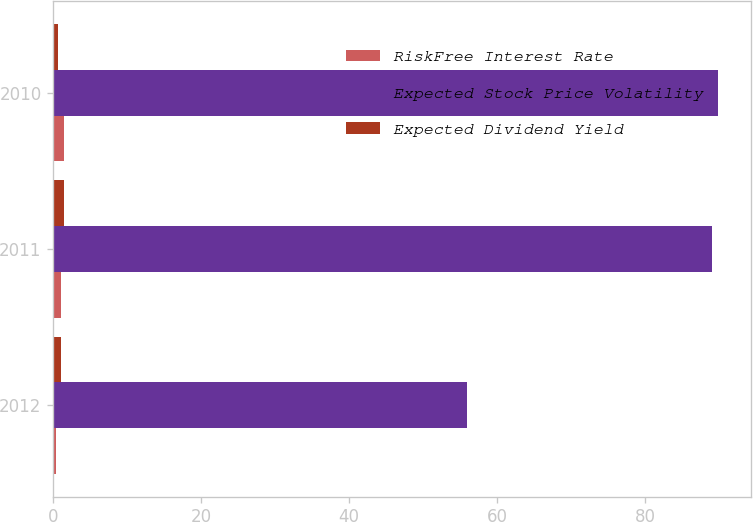Convert chart to OTSL. <chart><loc_0><loc_0><loc_500><loc_500><stacked_bar_chart><ecel><fcel>2012<fcel>2011<fcel>2010<nl><fcel>RiskFree Interest Rate<fcel>0.4<fcel>1<fcel>1.5<nl><fcel>Expected Stock Price Volatility<fcel>56<fcel>89<fcel>89.9<nl><fcel>Expected Dividend Yield<fcel>1.1<fcel>1.5<fcel>0.7<nl></chart> 